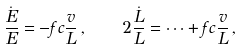Convert formula to latex. <formula><loc_0><loc_0><loc_500><loc_500>\frac { \dot { E } } { E } = - f c \frac { v } { L } \, , \quad 2 \frac { \dot { L } } { L } = \dots + f c \frac { v } { L } \, ,</formula> 